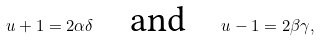Convert formula to latex. <formula><loc_0><loc_0><loc_500><loc_500>u + 1 = 2 \alpha \delta \text {\quad and\quad} u - 1 = 2 \beta \gamma ,</formula> 